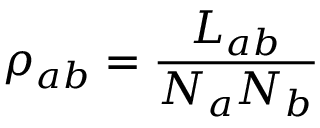<formula> <loc_0><loc_0><loc_500><loc_500>\rho _ { a b } = \frac { L _ { a b } } { N _ { a } N _ { b } }</formula> 